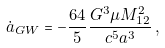Convert formula to latex. <formula><loc_0><loc_0><loc_500><loc_500>\dot { a } _ { G W } = - \frac { 6 4 } { 5 } \frac { G ^ { 3 } \mu M _ { 1 2 } ^ { 2 } } { c ^ { 5 } a ^ { 3 } } \, ,</formula> 